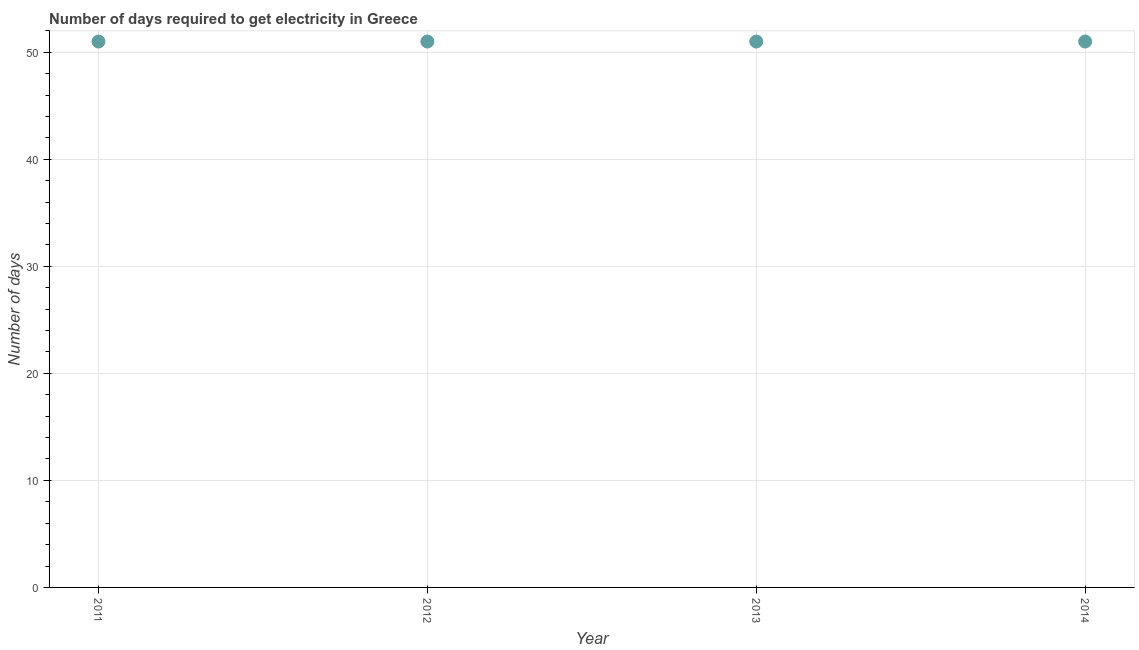What is the time to get electricity in 2013?
Make the answer very short. 51. Across all years, what is the maximum time to get electricity?
Give a very brief answer. 51. Across all years, what is the minimum time to get electricity?
Your answer should be compact. 51. In which year was the time to get electricity maximum?
Provide a succinct answer. 2011. In which year was the time to get electricity minimum?
Offer a terse response. 2011. What is the sum of the time to get electricity?
Make the answer very short. 204. What is the difference between the time to get electricity in 2011 and 2014?
Offer a terse response. 0. In how many years, is the time to get electricity greater than 44 ?
Offer a very short reply. 4. What is the ratio of the time to get electricity in 2013 to that in 2014?
Provide a succinct answer. 1. Is the difference between the time to get electricity in 2012 and 2013 greater than the difference between any two years?
Offer a very short reply. Yes. What is the difference between the highest and the second highest time to get electricity?
Ensure brevity in your answer.  0. Is the sum of the time to get electricity in 2011 and 2013 greater than the maximum time to get electricity across all years?
Make the answer very short. Yes. In how many years, is the time to get electricity greater than the average time to get electricity taken over all years?
Provide a short and direct response. 0. Does the time to get electricity monotonically increase over the years?
Your response must be concise. No. Are the values on the major ticks of Y-axis written in scientific E-notation?
Provide a short and direct response. No. Does the graph contain grids?
Your answer should be very brief. Yes. What is the title of the graph?
Give a very brief answer. Number of days required to get electricity in Greece. What is the label or title of the Y-axis?
Ensure brevity in your answer.  Number of days. What is the Number of days in 2011?
Your response must be concise. 51. What is the Number of days in 2013?
Provide a short and direct response. 51. What is the Number of days in 2014?
Offer a terse response. 51. What is the difference between the Number of days in 2011 and 2012?
Offer a terse response. 0. What is the difference between the Number of days in 2011 and 2014?
Offer a terse response. 0. What is the difference between the Number of days in 2012 and 2014?
Offer a very short reply. 0. What is the difference between the Number of days in 2013 and 2014?
Offer a terse response. 0. What is the ratio of the Number of days in 2011 to that in 2012?
Your response must be concise. 1. What is the ratio of the Number of days in 2011 to that in 2013?
Offer a terse response. 1. What is the ratio of the Number of days in 2012 to that in 2014?
Ensure brevity in your answer.  1. What is the ratio of the Number of days in 2013 to that in 2014?
Provide a short and direct response. 1. 